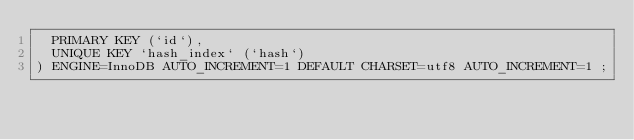<code> <loc_0><loc_0><loc_500><loc_500><_SQL_>  PRIMARY KEY (`id`),
  UNIQUE KEY `hash_index` (`hash`)
) ENGINE=InnoDB AUTO_INCREMENT=1 DEFAULT CHARSET=utf8 AUTO_INCREMENT=1 ;</code> 